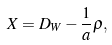<formula> <loc_0><loc_0><loc_500><loc_500>X = D _ { W } - \frac { 1 } { a } \rho ,</formula> 